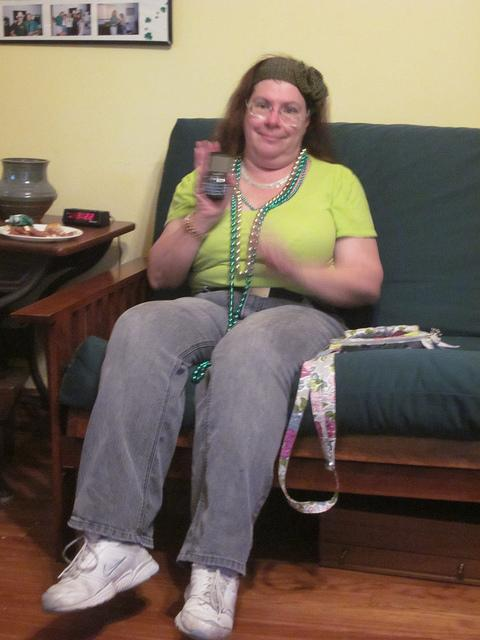What is the woman celebrating with her beads? mardi gras 